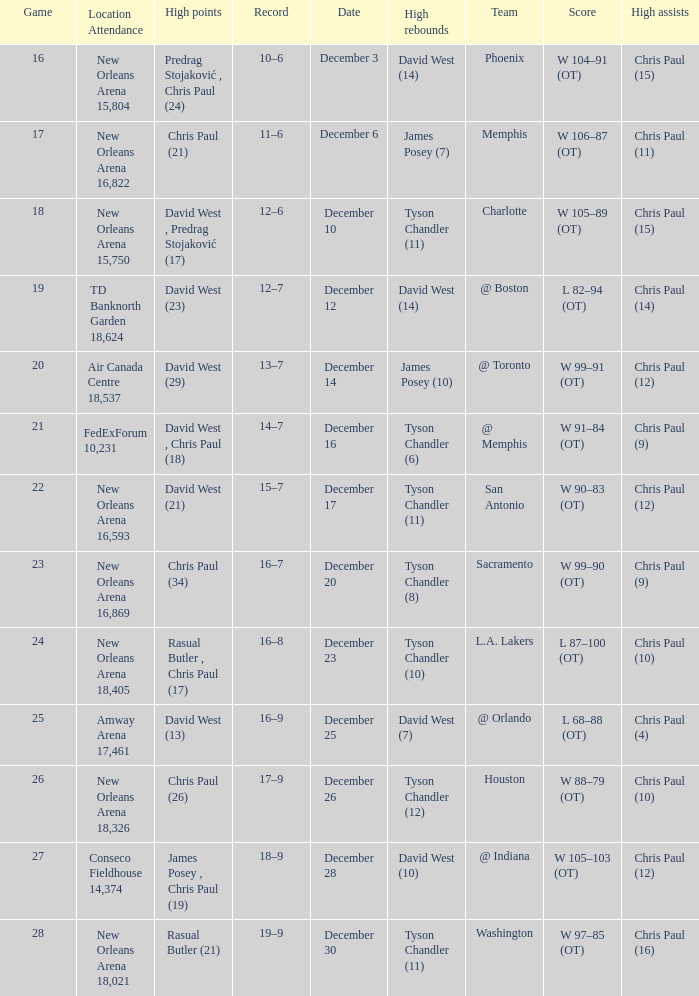What is Date, when Location Attendance is "TD Banknorth Garden 18,624"? December 12. 